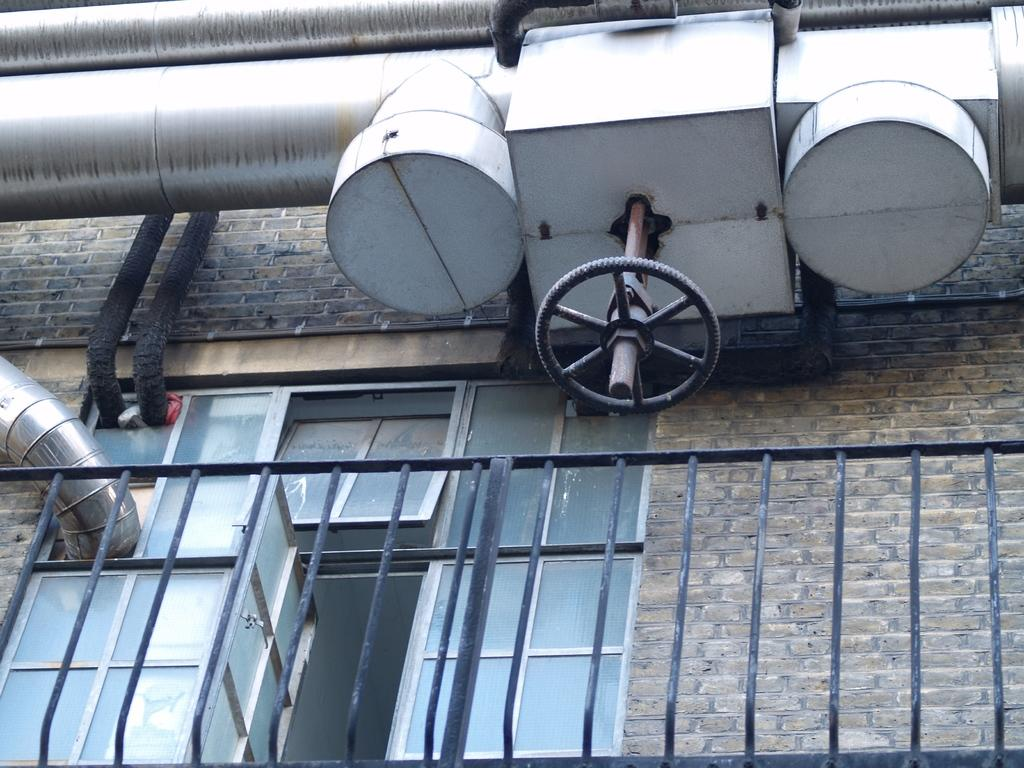What is located on the left side of the image? There is a window on the left side of the image. What is in front of the window? There is a boundary in front of the window. What can be seen at the top side of the image? There are pipes at the top side of the image. What type of gun is being used by the manager in the image? There is no manager or gun present in the image. What is being served for dinner in the image? There is no dinner or food being served in the image. 